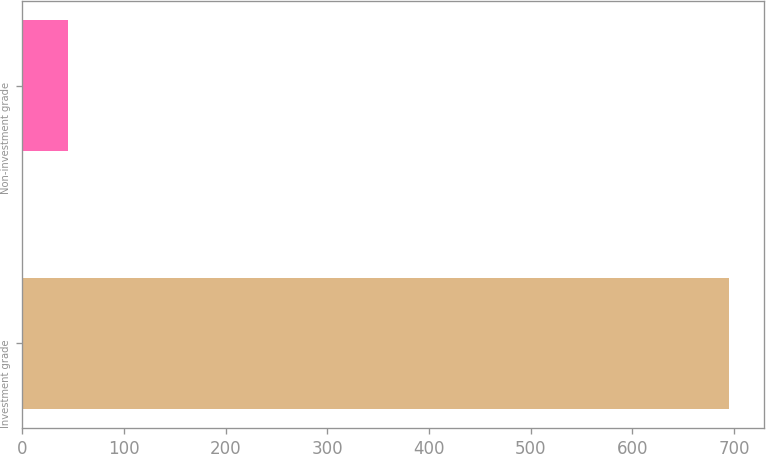Convert chart to OTSL. <chart><loc_0><loc_0><loc_500><loc_500><bar_chart><fcel>Investment grade<fcel>Non-investment grade<nl><fcel>695<fcel>45<nl></chart> 